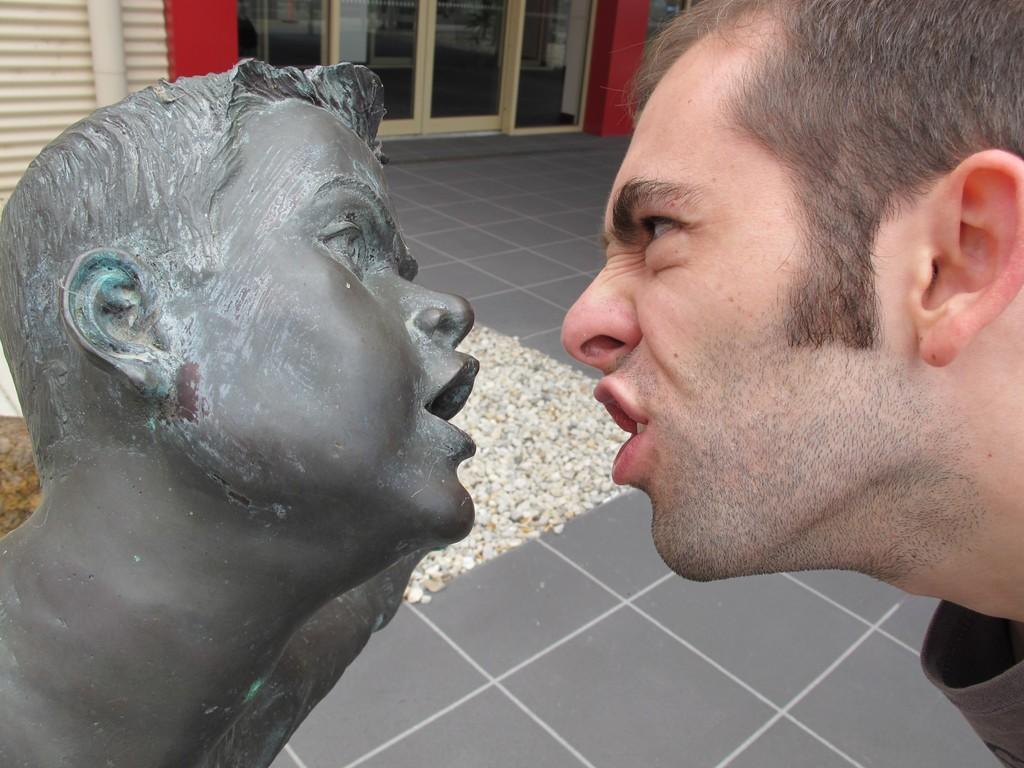Who or what is present in the image? There is a person and a statue in the image. What type of material is visible in the image? There are stones in the image. What architectural feature can be seen in the image? There is a wall in the image. What can be used for entering or exiting a space in the image? There are doors in the image. Is there a window in the image where the person is cooking? There is no window or cooking activity present in the image. 